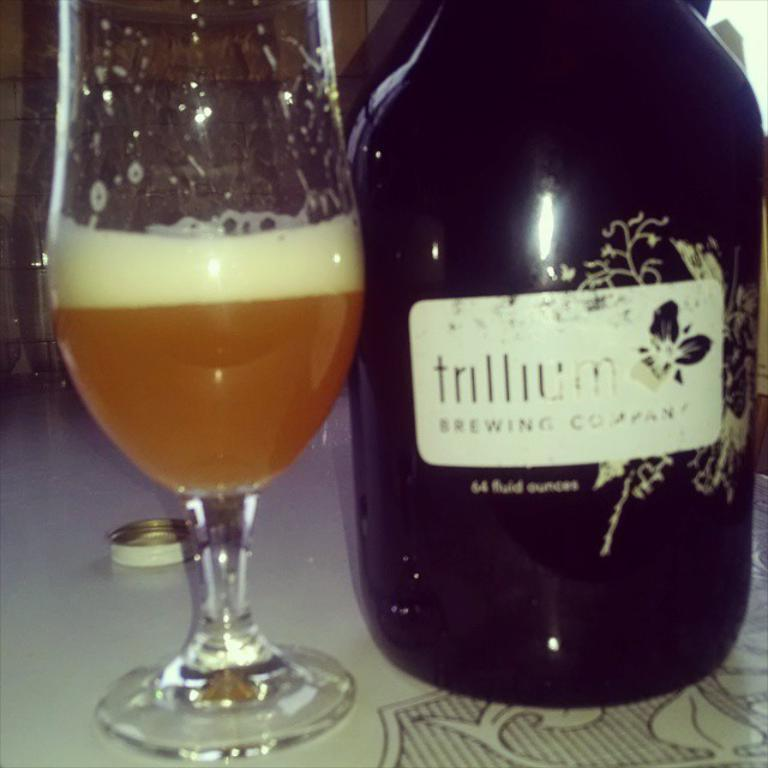<image>
Present a compact description of the photo's key features. A bottle of alcohol is adorned with its brewing company product label. 